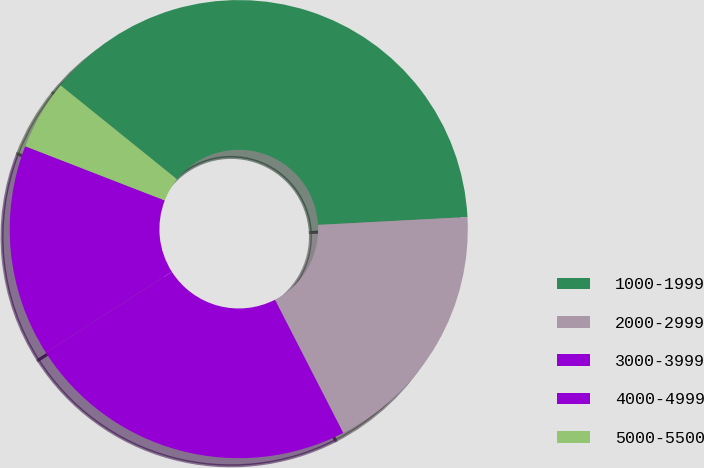Convert chart to OTSL. <chart><loc_0><loc_0><loc_500><loc_500><pie_chart><fcel>1000-1999<fcel>2000-2999<fcel>3000-3999<fcel>4000-4999<fcel>5000-5500<nl><fcel>38.35%<fcel>18.3%<fcel>23.48%<fcel>14.95%<fcel>4.91%<nl></chart> 